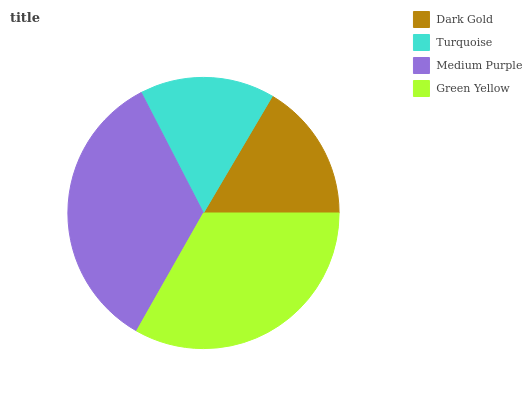Is Turquoise the minimum?
Answer yes or no. Yes. Is Medium Purple the maximum?
Answer yes or no. Yes. Is Medium Purple the minimum?
Answer yes or no. No. Is Turquoise the maximum?
Answer yes or no. No. Is Medium Purple greater than Turquoise?
Answer yes or no. Yes. Is Turquoise less than Medium Purple?
Answer yes or no. Yes. Is Turquoise greater than Medium Purple?
Answer yes or no. No. Is Medium Purple less than Turquoise?
Answer yes or no. No. Is Green Yellow the high median?
Answer yes or no. Yes. Is Dark Gold the low median?
Answer yes or no. Yes. Is Dark Gold the high median?
Answer yes or no. No. Is Medium Purple the low median?
Answer yes or no. No. 